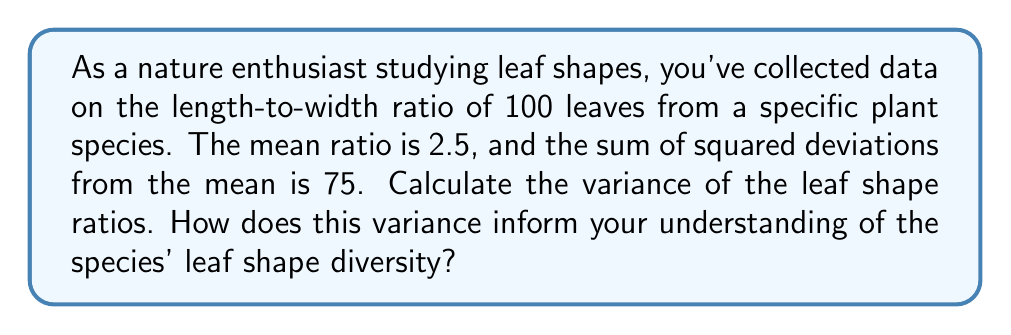Teach me how to tackle this problem. Let's approach this step-by-step:

1) The variance is a measure of variability in a dataset, calculated as the average squared deviation from the mean.

2) The formula for variance is:

   $$\sigma^2 = \frac{\sum (x_i - \mu)^2}{n}$$

   Where $\sigma^2$ is the variance, $x_i$ are individual values, $\mu$ is the mean, and $n$ is the number of observations.

3) We're given:
   - Number of leaves (n) = 100
   - Mean ratio ($\mu$) = 2.5
   - Sum of squared deviations $\sum (x_i - \mu)^2$ = 75

4) Plugging these values into the formula:

   $$\sigma^2 = \frac{75}{100} = 0.75$$

5) Therefore, the variance of the leaf shape ratios is 0.75.

6) Interpretation: The variance of 0.75 indicates moderate variability in leaf shapes. As a nature enthusiast, this suggests:
   - There's noticeable diversity in leaf shapes within this species.
   - The species shows some adaptability in leaf form, possibly due to environmental factors.
   - When creating digital art based on these leaves, you'd want to represent a range of shapes rather than a uniform design.
Answer: Variance = 0.75; Indicates moderate leaf shape diversity within the species. 